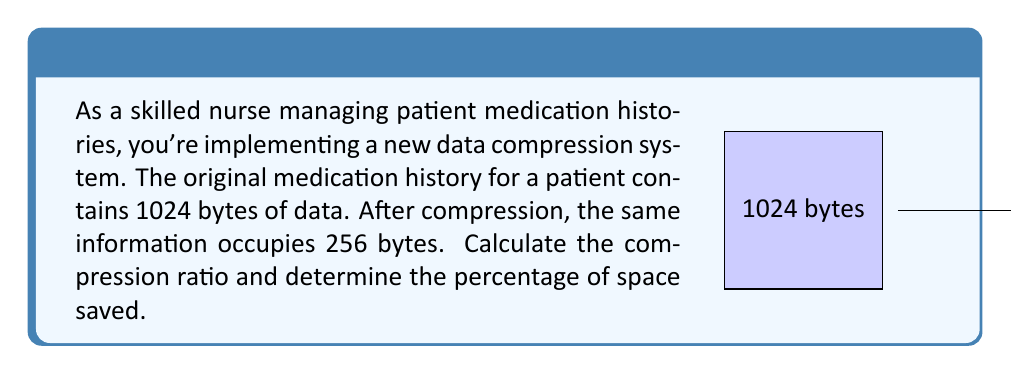Solve this math problem. To solve this problem, we'll follow these steps:

1) First, let's define the compression ratio:
   
   Compression Ratio = $\frac{\text{Uncompressed Size}}{\text{Compressed Size}}$

2) Given:
   - Uncompressed Size = 1024 bytes
   - Compressed Size = 256 bytes

3) Let's calculate the compression ratio:

   $$\text{Compression Ratio} = \frac{1024}{256} = 4$$

4) To calculate the percentage of space saved, we use the formula:

   $$\text{Space Saved (\%)} = \left(1 - \frac{\text{Compressed Size}}{\text{Uncompressed Size}}\right) \times 100\%$$

5) Plugging in our values:

   $$\text{Space Saved (\%)} = \left(1 - \frac{256}{1024}\right) \times 100\%$$

6) Simplify:

   $$\text{Space Saved (\%)} = \left(1 - \frac{1}{4}\right) \times 100\% = \frac{3}{4} \times 100\% = 75\%$$

Therefore, the compression ratio is 4:1, and the percentage of space saved is 75%.
Answer: 4:1 ratio; 75% space saved 